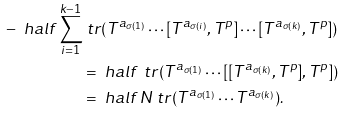<formula> <loc_0><loc_0><loc_500><loc_500>- \ h a l f \sum _ { i = 1 } ^ { k - 1 } & \ t r ( T ^ { a _ { \sigma ( 1 ) } } \cdots [ T ^ { a _ { \sigma ( i ) } } , T ^ { p } ] \cdots [ T ^ { a _ { \sigma ( k ) } } , T ^ { p } ] ) \\ & = \ h a l f \, \ t r ( T ^ { a _ { \sigma ( 1 ) } } \cdots [ [ T ^ { a _ { \sigma ( k ) } } , T ^ { p } ] , T ^ { p } ] ) \\ & = \ h a l f \, N \ t r ( T ^ { a _ { \sigma ( 1 ) } } \cdots T ^ { a _ { \sigma ( k ) } } ) .</formula> 